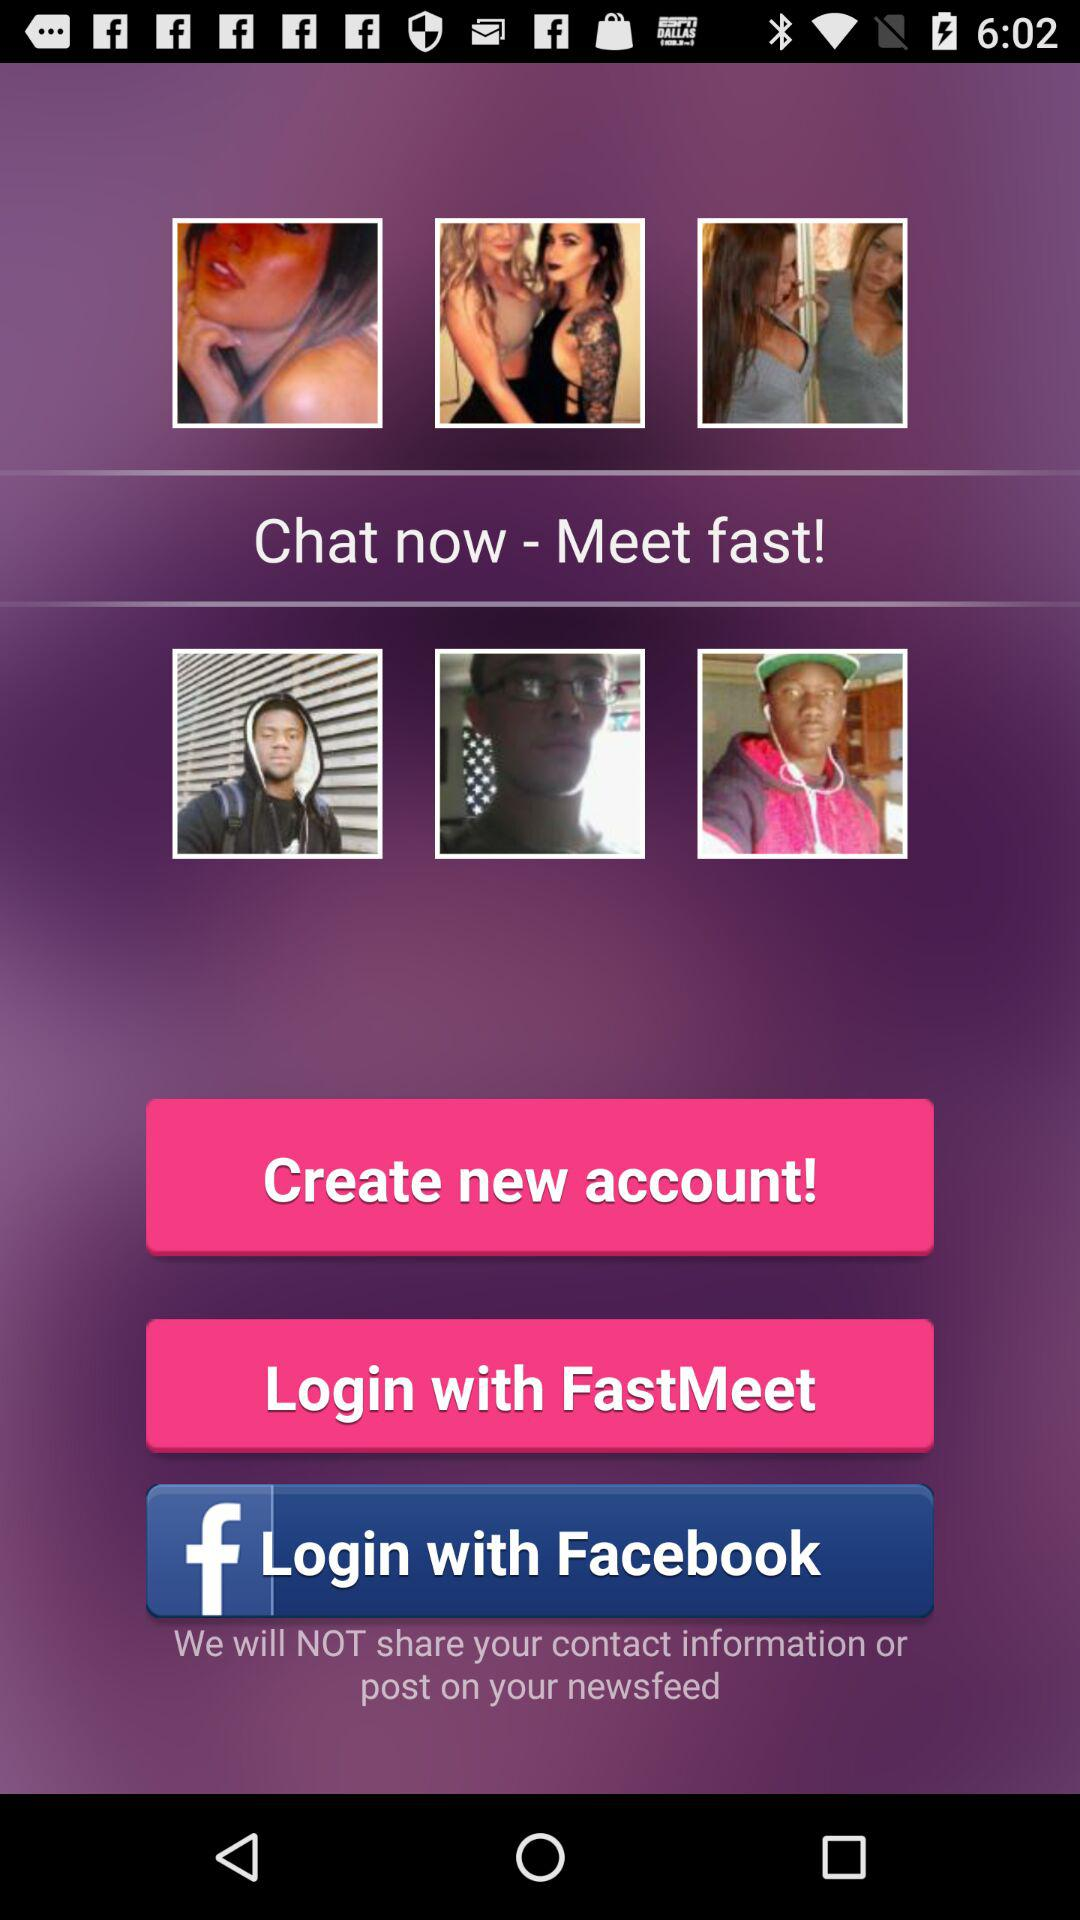What applications can be used to log in to a profile? You can log in to a profile with "FastMeet" and "Facebook". 